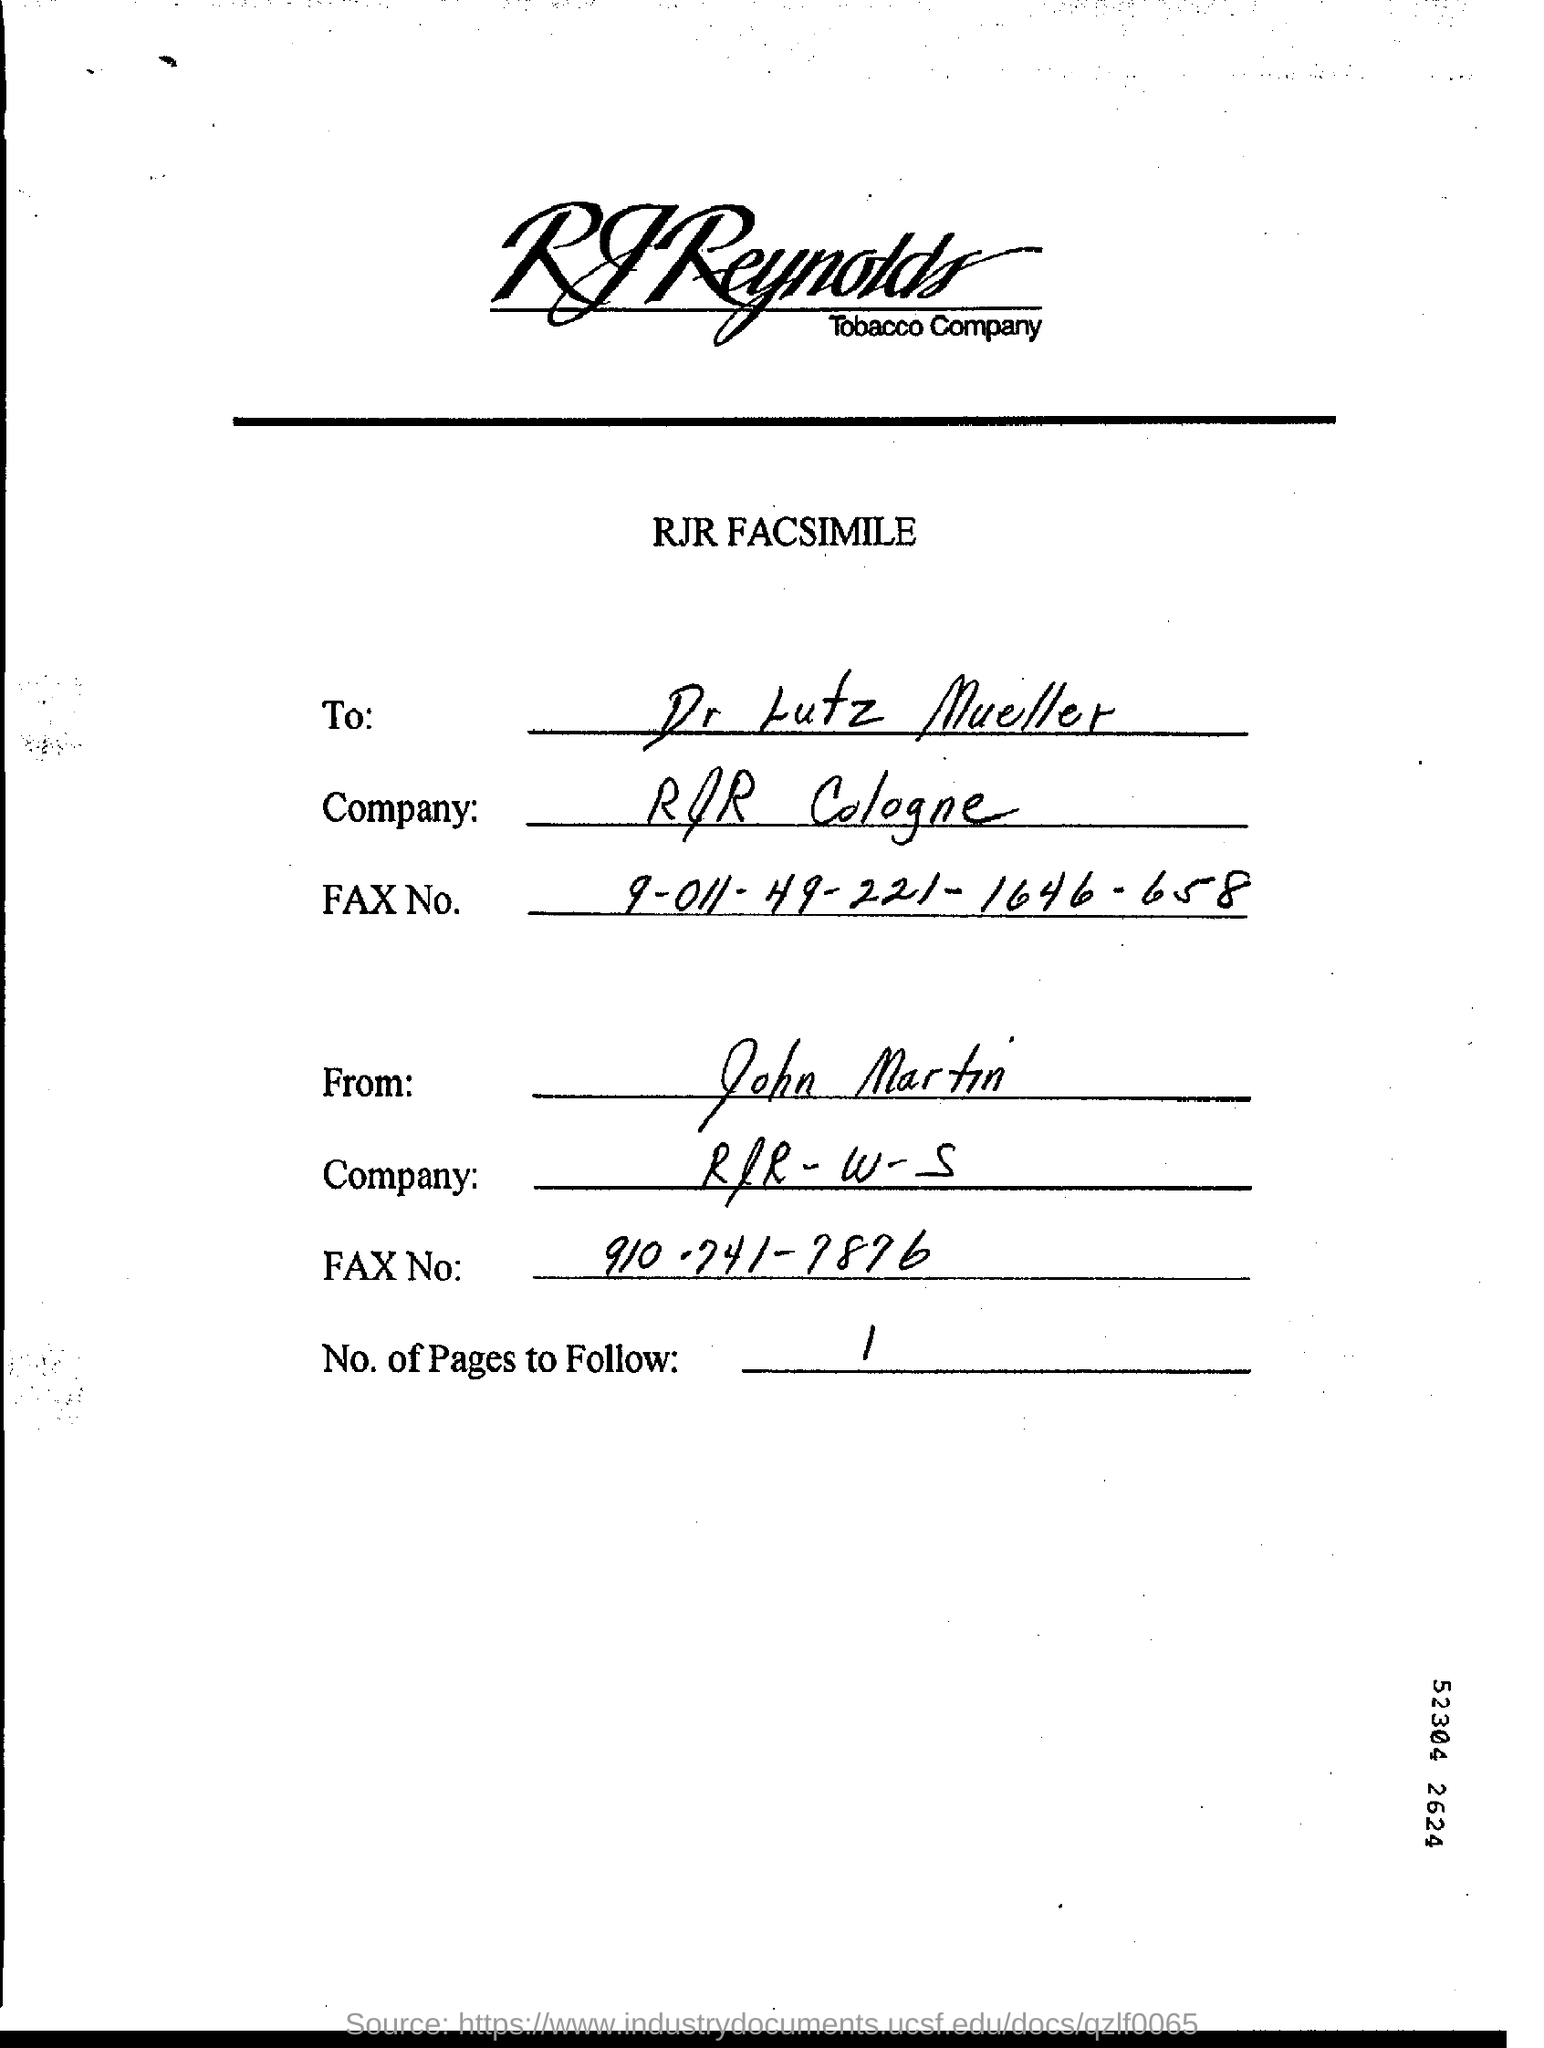To Whom is this letter addressed to?
Your response must be concise. Dr. Lutz Mueller. What is the Company to which it is addressed to?
Make the answer very short. RJR Cologne. Who is this letter from?
Offer a terse response. John martin. No. of Pages to Follow?
Your answer should be compact. 1. 